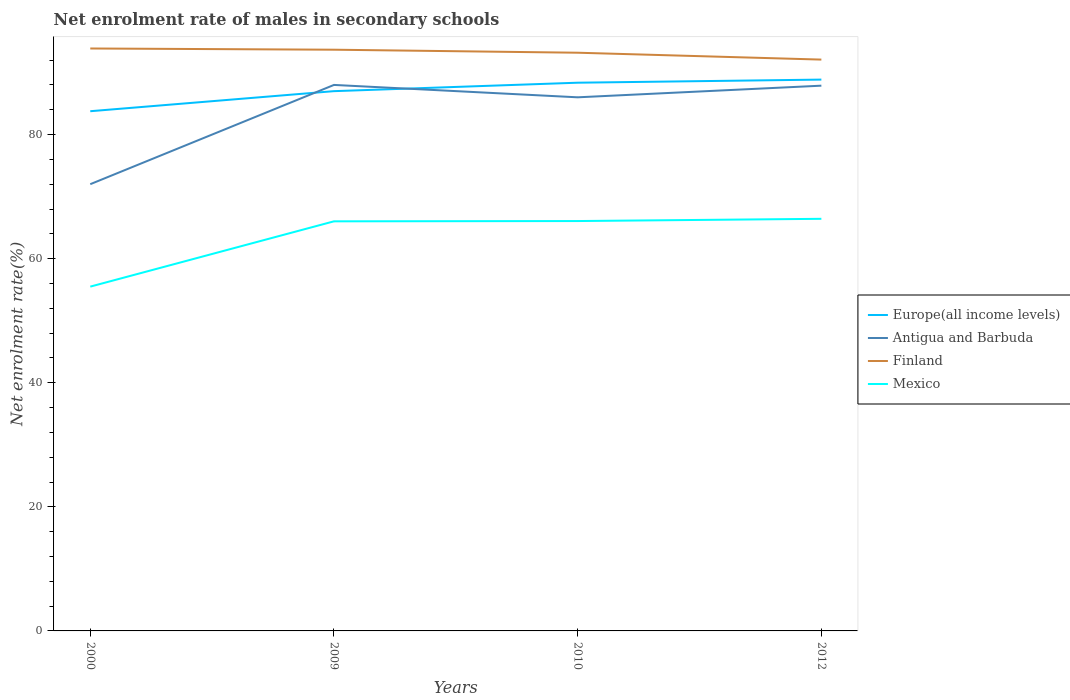How many different coloured lines are there?
Give a very brief answer. 4. Does the line corresponding to Europe(all income levels) intersect with the line corresponding to Mexico?
Provide a short and direct response. No. Is the number of lines equal to the number of legend labels?
Give a very brief answer. Yes. Across all years, what is the maximum net enrolment rate of males in secondary schools in Europe(all income levels)?
Offer a very short reply. 83.77. What is the total net enrolment rate of males in secondary schools in Mexico in the graph?
Your response must be concise. -10.93. What is the difference between the highest and the second highest net enrolment rate of males in secondary schools in Europe(all income levels)?
Keep it short and to the point. 5.1. What is the difference between the highest and the lowest net enrolment rate of males in secondary schools in Mexico?
Ensure brevity in your answer.  3. Is the net enrolment rate of males in secondary schools in Antigua and Barbuda strictly greater than the net enrolment rate of males in secondary schools in Finland over the years?
Make the answer very short. Yes. How many years are there in the graph?
Your answer should be very brief. 4. What is the difference between two consecutive major ticks on the Y-axis?
Make the answer very short. 20. Are the values on the major ticks of Y-axis written in scientific E-notation?
Keep it short and to the point. No. Does the graph contain any zero values?
Give a very brief answer. No. Where does the legend appear in the graph?
Keep it short and to the point. Center right. How many legend labels are there?
Provide a succinct answer. 4. How are the legend labels stacked?
Provide a short and direct response. Vertical. What is the title of the graph?
Give a very brief answer. Net enrolment rate of males in secondary schools. Does "Poland" appear as one of the legend labels in the graph?
Ensure brevity in your answer.  No. What is the label or title of the X-axis?
Your response must be concise. Years. What is the label or title of the Y-axis?
Your response must be concise. Net enrolment rate(%). What is the Net enrolment rate(%) of Europe(all income levels) in 2000?
Keep it short and to the point. 83.77. What is the Net enrolment rate(%) of Antigua and Barbuda in 2000?
Your response must be concise. 72.01. What is the Net enrolment rate(%) of Finland in 2000?
Offer a terse response. 93.88. What is the Net enrolment rate(%) of Mexico in 2000?
Provide a succinct answer. 55.49. What is the Net enrolment rate(%) of Europe(all income levels) in 2009?
Keep it short and to the point. 87. What is the Net enrolment rate(%) in Antigua and Barbuda in 2009?
Keep it short and to the point. 88. What is the Net enrolment rate(%) of Finland in 2009?
Your response must be concise. 93.68. What is the Net enrolment rate(%) of Mexico in 2009?
Provide a short and direct response. 66.02. What is the Net enrolment rate(%) in Europe(all income levels) in 2010?
Your answer should be very brief. 88.36. What is the Net enrolment rate(%) of Antigua and Barbuda in 2010?
Provide a succinct answer. 86.01. What is the Net enrolment rate(%) of Finland in 2010?
Ensure brevity in your answer.  93.19. What is the Net enrolment rate(%) in Mexico in 2010?
Provide a succinct answer. 66.06. What is the Net enrolment rate(%) of Europe(all income levels) in 2012?
Give a very brief answer. 88.86. What is the Net enrolment rate(%) in Antigua and Barbuda in 2012?
Make the answer very short. 87.88. What is the Net enrolment rate(%) in Finland in 2012?
Your answer should be very brief. 92.09. What is the Net enrolment rate(%) in Mexico in 2012?
Make the answer very short. 66.42. Across all years, what is the maximum Net enrolment rate(%) in Europe(all income levels)?
Ensure brevity in your answer.  88.86. Across all years, what is the maximum Net enrolment rate(%) in Antigua and Barbuda?
Provide a short and direct response. 88. Across all years, what is the maximum Net enrolment rate(%) of Finland?
Your answer should be very brief. 93.88. Across all years, what is the maximum Net enrolment rate(%) in Mexico?
Keep it short and to the point. 66.42. Across all years, what is the minimum Net enrolment rate(%) in Europe(all income levels)?
Offer a terse response. 83.77. Across all years, what is the minimum Net enrolment rate(%) of Antigua and Barbuda?
Your answer should be very brief. 72.01. Across all years, what is the minimum Net enrolment rate(%) in Finland?
Make the answer very short. 92.09. Across all years, what is the minimum Net enrolment rate(%) in Mexico?
Your answer should be compact. 55.49. What is the total Net enrolment rate(%) in Europe(all income levels) in the graph?
Offer a terse response. 347.99. What is the total Net enrolment rate(%) of Antigua and Barbuda in the graph?
Provide a short and direct response. 333.9. What is the total Net enrolment rate(%) in Finland in the graph?
Keep it short and to the point. 372.84. What is the total Net enrolment rate(%) in Mexico in the graph?
Ensure brevity in your answer.  254. What is the difference between the Net enrolment rate(%) in Europe(all income levels) in 2000 and that in 2009?
Provide a succinct answer. -3.23. What is the difference between the Net enrolment rate(%) in Antigua and Barbuda in 2000 and that in 2009?
Your answer should be very brief. -16. What is the difference between the Net enrolment rate(%) in Finland in 2000 and that in 2009?
Provide a succinct answer. 0.2. What is the difference between the Net enrolment rate(%) in Mexico in 2000 and that in 2009?
Provide a short and direct response. -10.52. What is the difference between the Net enrolment rate(%) of Europe(all income levels) in 2000 and that in 2010?
Keep it short and to the point. -4.6. What is the difference between the Net enrolment rate(%) in Antigua and Barbuda in 2000 and that in 2010?
Offer a terse response. -14. What is the difference between the Net enrolment rate(%) of Finland in 2000 and that in 2010?
Make the answer very short. 0.68. What is the difference between the Net enrolment rate(%) in Mexico in 2000 and that in 2010?
Provide a short and direct response. -10.57. What is the difference between the Net enrolment rate(%) of Europe(all income levels) in 2000 and that in 2012?
Ensure brevity in your answer.  -5.1. What is the difference between the Net enrolment rate(%) in Antigua and Barbuda in 2000 and that in 2012?
Your response must be concise. -15.88. What is the difference between the Net enrolment rate(%) in Finland in 2000 and that in 2012?
Give a very brief answer. 1.79. What is the difference between the Net enrolment rate(%) of Mexico in 2000 and that in 2012?
Provide a succinct answer. -10.93. What is the difference between the Net enrolment rate(%) in Europe(all income levels) in 2009 and that in 2010?
Give a very brief answer. -1.36. What is the difference between the Net enrolment rate(%) in Antigua and Barbuda in 2009 and that in 2010?
Your response must be concise. 2. What is the difference between the Net enrolment rate(%) in Finland in 2009 and that in 2010?
Ensure brevity in your answer.  0.49. What is the difference between the Net enrolment rate(%) of Mexico in 2009 and that in 2010?
Your answer should be compact. -0.05. What is the difference between the Net enrolment rate(%) in Europe(all income levels) in 2009 and that in 2012?
Make the answer very short. -1.86. What is the difference between the Net enrolment rate(%) of Antigua and Barbuda in 2009 and that in 2012?
Your answer should be very brief. 0.12. What is the difference between the Net enrolment rate(%) in Finland in 2009 and that in 2012?
Your answer should be very brief. 1.59. What is the difference between the Net enrolment rate(%) of Mexico in 2009 and that in 2012?
Give a very brief answer. -0.41. What is the difference between the Net enrolment rate(%) in Europe(all income levels) in 2010 and that in 2012?
Your answer should be very brief. -0.5. What is the difference between the Net enrolment rate(%) of Antigua and Barbuda in 2010 and that in 2012?
Keep it short and to the point. -1.87. What is the difference between the Net enrolment rate(%) of Finland in 2010 and that in 2012?
Your answer should be very brief. 1.11. What is the difference between the Net enrolment rate(%) of Mexico in 2010 and that in 2012?
Provide a short and direct response. -0.36. What is the difference between the Net enrolment rate(%) in Europe(all income levels) in 2000 and the Net enrolment rate(%) in Antigua and Barbuda in 2009?
Keep it short and to the point. -4.24. What is the difference between the Net enrolment rate(%) in Europe(all income levels) in 2000 and the Net enrolment rate(%) in Finland in 2009?
Keep it short and to the point. -9.91. What is the difference between the Net enrolment rate(%) of Europe(all income levels) in 2000 and the Net enrolment rate(%) of Mexico in 2009?
Your answer should be very brief. 17.75. What is the difference between the Net enrolment rate(%) of Antigua and Barbuda in 2000 and the Net enrolment rate(%) of Finland in 2009?
Offer a very short reply. -21.68. What is the difference between the Net enrolment rate(%) in Antigua and Barbuda in 2000 and the Net enrolment rate(%) in Mexico in 2009?
Provide a succinct answer. 5.99. What is the difference between the Net enrolment rate(%) of Finland in 2000 and the Net enrolment rate(%) of Mexico in 2009?
Offer a terse response. 27.86. What is the difference between the Net enrolment rate(%) in Europe(all income levels) in 2000 and the Net enrolment rate(%) in Antigua and Barbuda in 2010?
Offer a very short reply. -2.24. What is the difference between the Net enrolment rate(%) of Europe(all income levels) in 2000 and the Net enrolment rate(%) of Finland in 2010?
Offer a very short reply. -9.43. What is the difference between the Net enrolment rate(%) of Europe(all income levels) in 2000 and the Net enrolment rate(%) of Mexico in 2010?
Provide a short and direct response. 17.7. What is the difference between the Net enrolment rate(%) of Antigua and Barbuda in 2000 and the Net enrolment rate(%) of Finland in 2010?
Provide a short and direct response. -21.19. What is the difference between the Net enrolment rate(%) of Antigua and Barbuda in 2000 and the Net enrolment rate(%) of Mexico in 2010?
Your answer should be very brief. 5.94. What is the difference between the Net enrolment rate(%) of Finland in 2000 and the Net enrolment rate(%) of Mexico in 2010?
Provide a short and direct response. 27.81. What is the difference between the Net enrolment rate(%) of Europe(all income levels) in 2000 and the Net enrolment rate(%) of Antigua and Barbuda in 2012?
Keep it short and to the point. -4.12. What is the difference between the Net enrolment rate(%) in Europe(all income levels) in 2000 and the Net enrolment rate(%) in Finland in 2012?
Your answer should be compact. -8.32. What is the difference between the Net enrolment rate(%) of Europe(all income levels) in 2000 and the Net enrolment rate(%) of Mexico in 2012?
Offer a very short reply. 17.34. What is the difference between the Net enrolment rate(%) in Antigua and Barbuda in 2000 and the Net enrolment rate(%) in Finland in 2012?
Offer a terse response. -20.08. What is the difference between the Net enrolment rate(%) in Antigua and Barbuda in 2000 and the Net enrolment rate(%) in Mexico in 2012?
Make the answer very short. 5.58. What is the difference between the Net enrolment rate(%) of Finland in 2000 and the Net enrolment rate(%) of Mexico in 2012?
Offer a terse response. 27.45. What is the difference between the Net enrolment rate(%) of Europe(all income levels) in 2009 and the Net enrolment rate(%) of Antigua and Barbuda in 2010?
Make the answer very short. 0.99. What is the difference between the Net enrolment rate(%) of Europe(all income levels) in 2009 and the Net enrolment rate(%) of Finland in 2010?
Make the answer very short. -6.19. What is the difference between the Net enrolment rate(%) of Europe(all income levels) in 2009 and the Net enrolment rate(%) of Mexico in 2010?
Ensure brevity in your answer.  20.94. What is the difference between the Net enrolment rate(%) of Antigua and Barbuda in 2009 and the Net enrolment rate(%) of Finland in 2010?
Offer a terse response. -5.19. What is the difference between the Net enrolment rate(%) in Antigua and Barbuda in 2009 and the Net enrolment rate(%) in Mexico in 2010?
Your answer should be compact. 21.94. What is the difference between the Net enrolment rate(%) of Finland in 2009 and the Net enrolment rate(%) of Mexico in 2010?
Your answer should be very brief. 27.62. What is the difference between the Net enrolment rate(%) in Europe(all income levels) in 2009 and the Net enrolment rate(%) in Antigua and Barbuda in 2012?
Make the answer very short. -0.88. What is the difference between the Net enrolment rate(%) of Europe(all income levels) in 2009 and the Net enrolment rate(%) of Finland in 2012?
Offer a very short reply. -5.09. What is the difference between the Net enrolment rate(%) of Europe(all income levels) in 2009 and the Net enrolment rate(%) of Mexico in 2012?
Ensure brevity in your answer.  20.58. What is the difference between the Net enrolment rate(%) in Antigua and Barbuda in 2009 and the Net enrolment rate(%) in Finland in 2012?
Ensure brevity in your answer.  -4.08. What is the difference between the Net enrolment rate(%) of Antigua and Barbuda in 2009 and the Net enrolment rate(%) of Mexico in 2012?
Offer a very short reply. 21.58. What is the difference between the Net enrolment rate(%) in Finland in 2009 and the Net enrolment rate(%) in Mexico in 2012?
Provide a short and direct response. 27.26. What is the difference between the Net enrolment rate(%) of Europe(all income levels) in 2010 and the Net enrolment rate(%) of Antigua and Barbuda in 2012?
Provide a succinct answer. 0.48. What is the difference between the Net enrolment rate(%) in Europe(all income levels) in 2010 and the Net enrolment rate(%) in Finland in 2012?
Ensure brevity in your answer.  -3.72. What is the difference between the Net enrolment rate(%) of Europe(all income levels) in 2010 and the Net enrolment rate(%) of Mexico in 2012?
Your answer should be very brief. 21.94. What is the difference between the Net enrolment rate(%) in Antigua and Barbuda in 2010 and the Net enrolment rate(%) in Finland in 2012?
Provide a succinct answer. -6.08. What is the difference between the Net enrolment rate(%) of Antigua and Barbuda in 2010 and the Net enrolment rate(%) of Mexico in 2012?
Provide a short and direct response. 19.58. What is the difference between the Net enrolment rate(%) of Finland in 2010 and the Net enrolment rate(%) of Mexico in 2012?
Ensure brevity in your answer.  26.77. What is the average Net enrolment rate(%) of Europe(all income levels) per year?
Provide a succinct answer. 87. What is the average Net enrolment rate(%) of Antigua and Barbuda per year?
Keep it short and to the point. 83.47. What is the average Net enrolment rate(%) of Finland per year?
Provide a succinct answer. 93.21. What is the average Net enrolment rate(%) in Mexico per year?
Your response must be concise. 63.5. In the year 2000, what is the difference between the Net enrolment rate(%) in Europe(all income levels) and Net enrolment rate(%) in Antigua and Barbuda?
Offer a very short reply. 11.76. In the year 2000, what is the difference between the Net enrolment rate(%) in Europe(all income levels) and Net enrolment rate(%) in Finland?
Give a very brief answer. -10.11. In the year 2000, what is the difference between the Net enrolment rate(%) in Europe(all income levels) and Net enrolment rate(%) in Mexico?
Offer a terse response. 28.27. In the year 2000, what is the difference between the Net enrolment rate(%) of Antigua and Barbuda and Net enrolment rate(%) of Finland?
Provide a succinct answer. -21.87. In the year 2000, what is the difference between the Net enrolment rate(%) in Antigua and Barbuda and Net enrolment rate(%) in Mexico?
Offer a terse response. 16.51. In the year 2000, what is the difference between the Net enrolment rate(%) in Finland and Net enrolment rate(%) in Mexico?
Your answer should be compact. 38.38. In the year 2009, what is the difference between the Net enrolment rate(%) in Europe(all income levels) and Net enrolment rate(%) in Antigua and Barbuda?
Provide a short and direct response. -1. In the year 2009, what is the difference between the Net enrolment rate(%) of Europe(all income levels) and Net enrolment rate(%) of Finland?
Give a very brief answer. -6.68. In the year 2009, what is the difference between the Net enrolment rate(%) of Europe(all income levels) and Net enrolment rate(%) of Mexico?
Give a very brief answer. 20.98. In the year 2009, what is the difference between the Net enrolment rate(%) in Antigua and Barbuda and Net enrolment rate(%) in Finland?
Keep it short and to the point. -5.68. In the year 2009, what is the difference between the Net enrolment rate(%) in Antigua and Barbuda and Net enrolment rate(%) in Mexico?
Offer a terse response. 21.99. In the year 2009, what is the difference between the Net enrolment rate(%) in Finland and Net enrolment rate(%) in Mexico?
Keep it short and to the point. 27.66. In the year 2010, what is the difference between the Net enrolment rate(%) of Europe(all income levels) and Net enrolment rate(%) of Antigua and Barbuda?
Offer a very short reply. 2.35. In the year 2010, what is the difference between the Net enrolment rate(%) of Europe(all income levels) and Net enrolment rate(%) of Finland?
Provide a short and direct response. -4.83. In the year 2010, what is the difference between the Net enrolment rate(%) of Europe(all income levels) and Net enrolment rate(%) of Mexico?
Offer a terse response. 22.3. In the year 2010, what is the difference between the Net enrolment rate(%) in Antigua and Barbuda and Net enrolment rate(%) in Finland?
Ensure brevity in your answer.  -7.19. In the year 2010, what is the difference between the Net enrolment rate(%) of Antigua and Barbuda and Net enrolment rate(%) of Mexico?
Your response must be concise. 19.94. In the year 2010, what is the difference between the Net enrolment rate(%) in Finland and Net enrolment rate(%) in Mexico?
Give a very brief answer. 27.13. In the year 2012, what is the difference between the Net enrolment rate(%) of Europe(all income levels) and Net enrolment rate(%) of Antigua and Barbuda?
Give a very brief answer. 0.98. In the year 2012, what is the difference between the Net enrolment rate(%) in Europe(all income levels) and Net enrolment rate(%) in Finland?
Keep it short and to the point. -3.22. In the year 2012, what is the difference between the Net enrolment rate(%) in Europe(all income levels) and Net enrolment rate(%) in Mexico?
Offer a very short reply. 22.44. In the year 2012, what is the difference between the Net enrolment rate(%) in Antigua and Barbuda and Net enrolment rate(%) in Finland?
Keep it short and to the point. -4.2. In the year 2012, what is the difference between the Net enrolment rate(%) of Antigua and Barbuda and Net enrolment rate(%) of Mexico?
Offer a very short reply. 21.46. In the year 2012, what is the difference between the Net enrolment rate(%) in Finland and Net enrolment rate(%) in Mexico?
Your response must be concise. 25.66. What is the ratio of the Net enrolment rate(%) of Europe(all income levels) in 2000 to that in 2009?
Your answer should be compact. 0.96. What is the ratio of the Net enrolment rate(%) in Antigua and Barbuda in 2000 to that in 2009?
Your response must be concise. 0.82. What is the ratio of the Net enrolment rate(%) of Finland in 2000 to that in 2009?
Your answer should be compact. 1. What is the ratio of the Net enrolment rate(%) of Mexico in 2000 to that in 2009?
Provide a short and direct response. 0.84. What is the ratio of the Net enrolment rate(%) of Europe(all income levels) in 2000 to that in 2010?
Your response must be concise. 0.95. What is the ratio of the Net enrolment rate(%) of Antigua and Barbuda in 2000 to that in 2010?
Provide a succinct answer. 0.84. What is the ratio of the Net enrolment rate(%) in Finland in 2000 to that in 2010?
Ensure brevity in your answer.  1.01. What is the ratio of the Net enrolment rate(%) of Mexico in 2000 to that in 2010?
Provide a succinct answer. 0.84. What is the ratio of the Net enrolment rate(%) of Europe(all income levels) in 2000 to that in 2012?
Provide a succinct answer. 0.94. What is the ratio of the Net enrolment rate(%) in Antigua and Barbuda in 2000 to that in 2012?
Your answer should be very brief. 0.82. What is the ratio of the Net enrolment rate(%) of Finland in 2000 to that in 2012?
Offer a very short reply. 1.02. What is the ratio of the Net enrolment rate(%) in Mexico in 2000 to that in 2012?
Offer a very short reply. 0.84. What is the ratio of the Net enrolment rate(%) in Europe(all income levels) in 2009 to that in 2010?
Provide a short and direct response. 0.98. What is the ratio of the Net enrolment rate(%) of Antigua and Barbuda in 2009 to that in 2010?
Make the answer very short. 1.02. What is the ratio of the Net enrolment rate(%) of Finland in 2009 to that in 2010?
Your answer should be compact. 1.01. What is the ratio of the Net enrolment rate(%) in Mexico in 2009 to that in 2010?
Give a very brief answer. 1. What is the ratio of the Net enrolment rate(%) in Europe(all income levels) in 2009 to that in 2012?
Keep it short and to the point. 0.98. What is the ratio of the Net enrolment rate(%) of Antigua and Barbuda in 2009 to that in 2012?
Your response must be concise. 1. What is the ratio of the Net enrolment rate(%) of Finland in 2009 to that in 2012?
Your response must be concise. 1.02. What is the ratio of the Net enrolment rate(%) of Mexico in 2009 to that in 2012?
Keep it short and to the point. 0.99. What is the ratio of the Net enrolment rate(%) of Antigua and Barbuda in 2010 to that in 2012?
Provide a succinct answer. 0.98. What is the ratio of the Net enrolment rate(%) of Mexico in 2010 to that in 2012?
Provide a succinct answer. 0.99. What is the difference between the highest and the second highest Net enrolment rate(%) of Europe(all income levels)?
Give a very brief answer. 0.5. What is the difference between the highest and the second highest Net enrolment rate(%) of Antigua and Barbuda?
Your response must be concise. 0.12. What is the difference between the highest and the second highest Net enrolment rate(%) in Finland?
Your answer should be compact. 0.2. What is the difference between the highest and the second highest Net enrolment rate(%) of Mexico?
Provide a short and direct response. 0.36. What is the difference between the highest and the lowest Net enrolment rate(%) in Europe(all income levels)?
Provide a succinct answer. 5.1. What is the difference between the highest and the lowest Net enrolment rate(%) of Antigua and Barbuda?
Provide a short and direct response. 16. What is the difference between the highest and the lowest Net enrolment rate(%) of Finland?
Your response must be concise. 1.79. What is the difference between the highest and the lowest Net enrolment rate(%) of Mexico?
Your response must be concise. 10.93. 